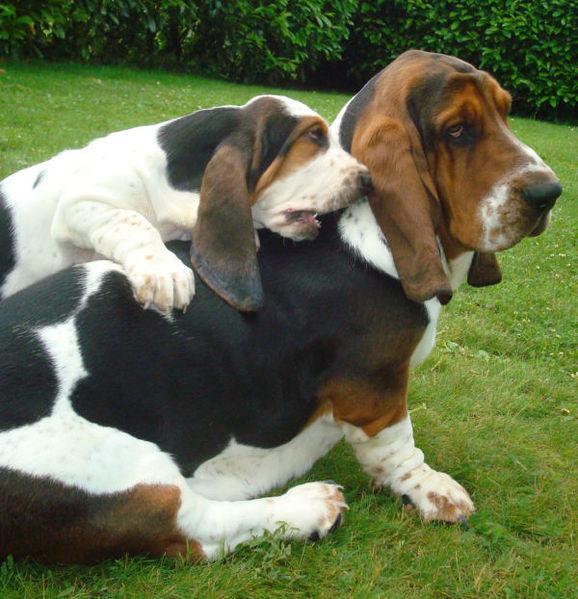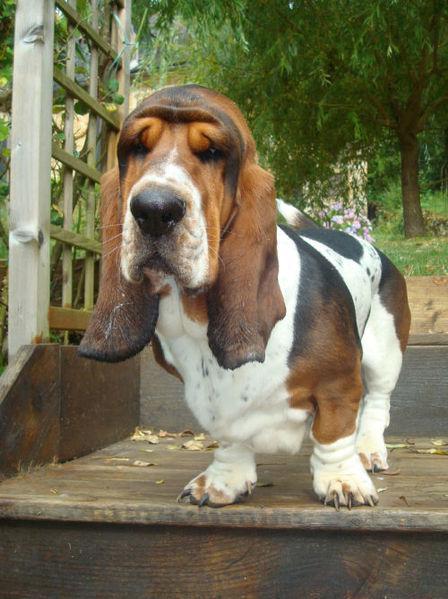The first image is the image on the left, the second image is the image on the right. Evaluate the accuracy of this statement regarding the images: "A sitting basset hound is interacting with one smaller basset hound on the grass.". Is it true? Answer yes or no. Yes. The first image is the image on the left, the second image is the image on the right. Given the left and right images, does the statement "A single dog is standing int he grass in one of the images." hold true? Answer yes or no. No. 